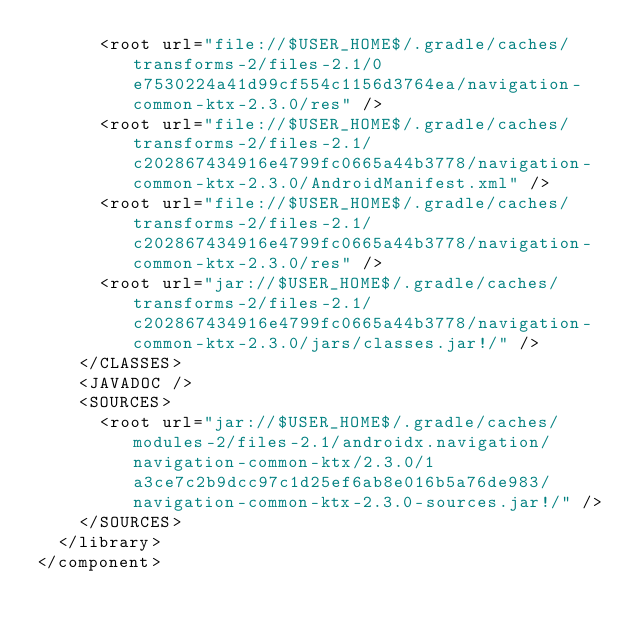<code> <loc_0><loc_0><loc_500><loc_500><_XML_>      <root url="file://$USER_HOME$/.gradle/caches/transforms-2/files-2.1/0e7530224a41d99cf554c1156d3764ea/navigation-common-ktx-2.3.0/res" />
      <root url="file://$USER_HOME$/.gradle/caches/transforms-2/files-2.1/c202867434916e4799fc0665a44b3778/navigation-common-ktx-2.3.0/AndroidManifest.xml" />
      <root url="file://$USER_HOME$/.gradle/caches/transforms-2/files-2.1/c202867434916e4799fc0665a44b3778/navigation-common-ktx-2.3.0/res" />
      <root url="jar://$USER_HOME$/.gradle/caches/transforms-2/files-2.1/c202867434916e4799fc0665a44b3778/navigation-common-ktx-2.3.0/jars/classes.jar!/" />
    </CLASSES>
    <JAVADOC />
    <SOURCES>
      <root url="jar://$USER_HOME$/.gradle/caches/modules-2/files-2.1/androidx.navigation/navigation-common-ktx/2.3.0/1a3ce7c2b9dcc97c1d25ef6ab8e016b5a76de983/navigation-common-ktx-2.3.0-sources.jar!/" />
    </SOURCES>
  </library>
</component></code> 